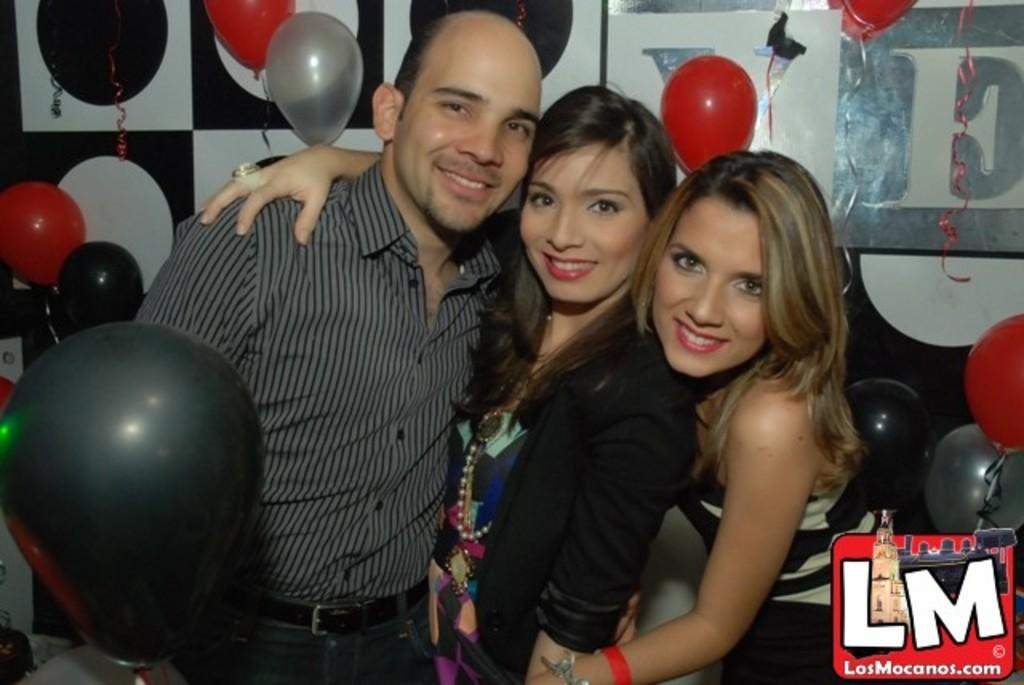What are the people in the image doing? The people in the image are standing and smiling. What can be seen in the image besides the people? There are colorful balloons in the image. What is visible in the background of the image? There are boards visible in the background of the image. What type of act are the people performing in the image? There is no specific act being performed by the people in the image; they are simply standing and smiling. What is the people's wish in the image? There is no indication of a specific wish in the image; the people are simply smiling. 